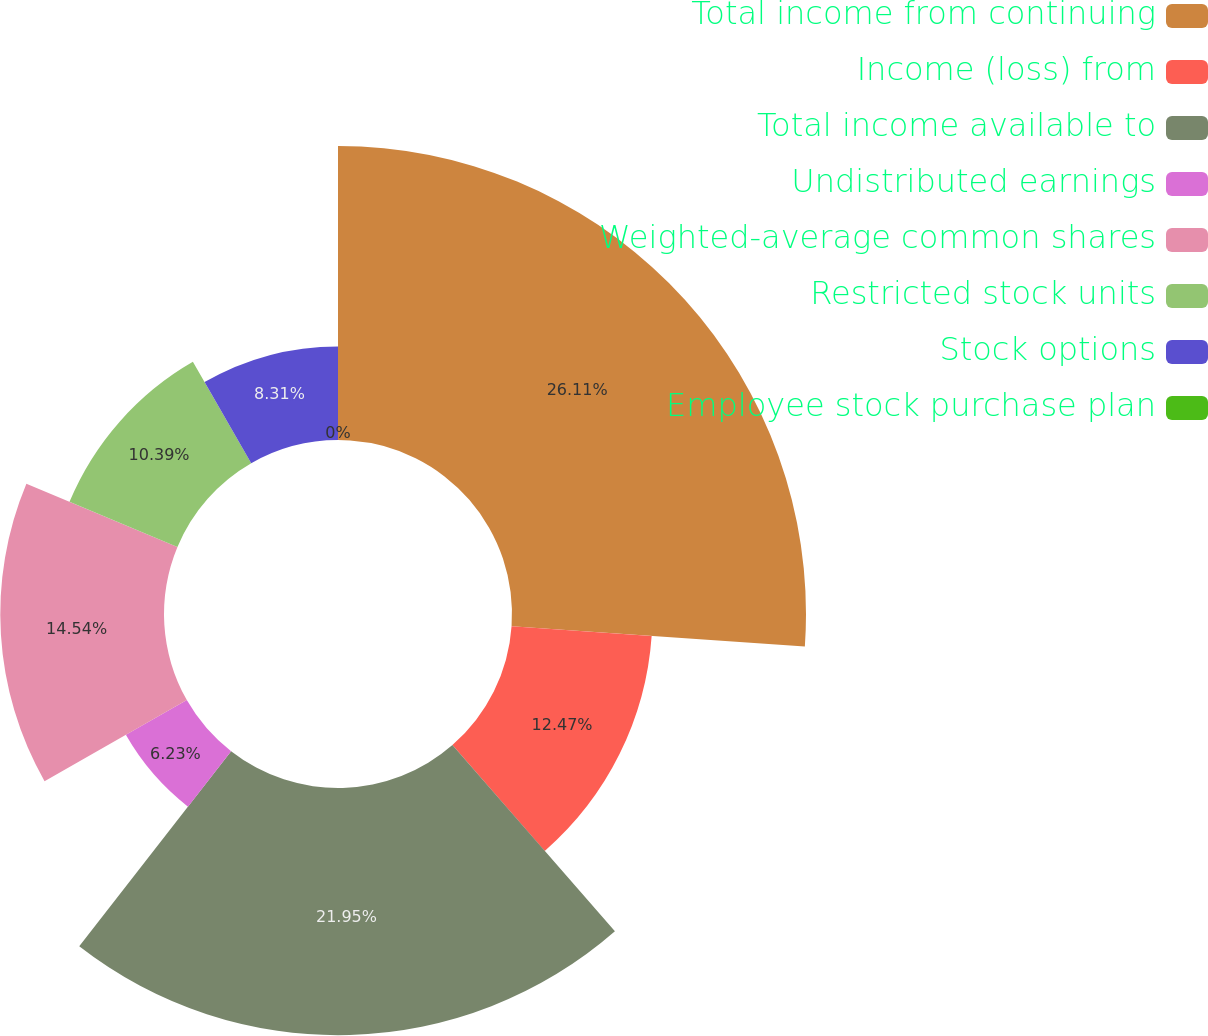<chart> <loc_0><loc_0><loc_500><loc_500><pie_chart><fcel>Total income from continuing<fcel>Income (loss) from<fcel>Total income available to<fcel>Undistributed earnings<fcel>Weighted-average common shares<fcel>Restricted stock units<fcel>Stock options<fcel>Employee stock purchase plan<nl><fcel>26.11%<fcel>12.47%<fcel>21.95%<fcel>6.23%<fcel>14.54%<fcel>10.39%<fcel>8.31%<fcel>0.0%<nl></chart> 